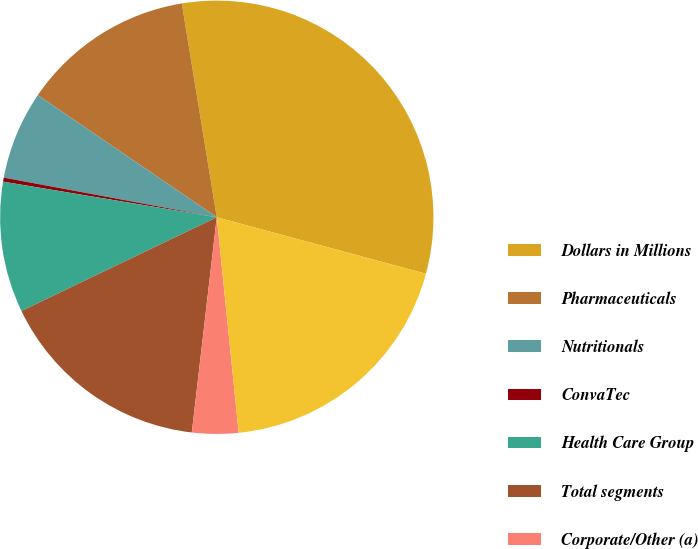Convert chart to OTSL. <chart><loc_0><loc_0><loc_500><loc_500><pie_chart><fcel>Dollars in Millions<fcel>Pharmaceuticals<fcel>Nutritionals<fcel>ConvaTec<fcel>Health Care Group<fcel>Total segments<fcel>Corporate/Other (a)<fcel>Total<nl><fcel>31.78%<fcel>12.89%<fcel>6.6%<fcel>0.3%<fcel>9.75%<fcel>16.04%<fcel>3.45%<fcel>19.19%<nl></chart> 